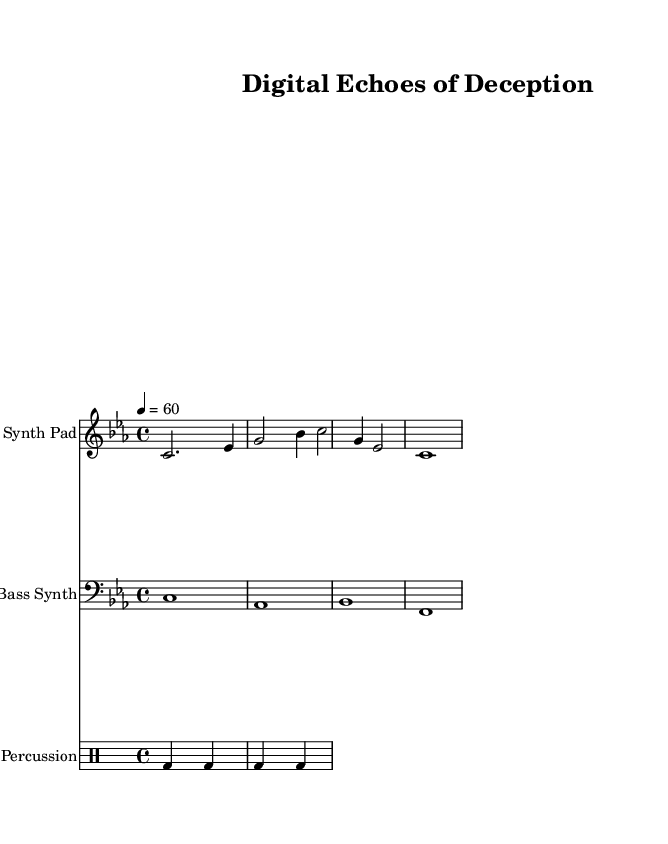What is the key signature of this music? The key signature is C minor, which is indicated by three flats (B flat, E flat, and A flat) in the key signature.
Answer: C minor What is the time signature of this music? The time signature is shown as 4/4, indicating four beats in each measure and a quarter note receives one beat.
Answer: 4/4 What is the tempo marking for this piece? The tempo marking states "4 = 60," meaning that there are 60 beats per minute, with quarter notes receiving one beat.
Answer: 60 How many beats are in the first measure of the Synth Pad part? The first measure consists of a half note lasting 2 beats and a quarter note lasting 1 beat, for a total of 3 beats counted. Therefore, the remaining 1 beat must come from the last note, which is a quarter note.
Answer: 4 What type of synth is used as the Bass instrument? The Bass instrument in this composition is labeled as "Bass Synth," which describes its electronic sound quality distinctive to ambient music.
Answer: Bass Synth How often does the bass synth change notes in its part? The bass synth part consists of whole notes, meaning it holds each note for the entire measure without changing until the next measure begins.
Answer: Every measure What is the rhythmic structure for the percussion section? The percussion section consists of a bass drum on beats 1 and 3, and is structured with a consistent pattern of beats and rests (s) across two measures.
Answer: Alternating beats and rests 